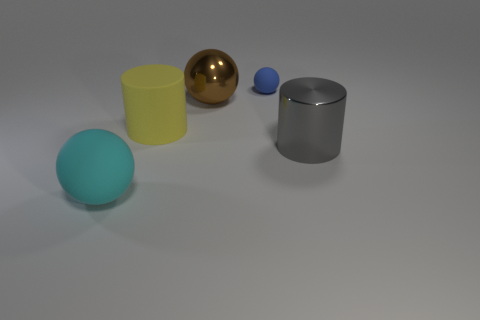Subtract all rubber spheres. How many spheres are left? 1 Add 4 large cyan metal cubes. How many objects exist? 9 Subtract all spheres. How many objects are left? 2 Add 4 big brown things. How many big brown things exist? 5 Subtract 1 gray cylinders. How many objects are left? 4 Subtract all small blue objects. Subtract all big gray metallic cylinders. How many objects are left? 3 Add 4 brown metallic things. How many brown metallic things are left? 5 